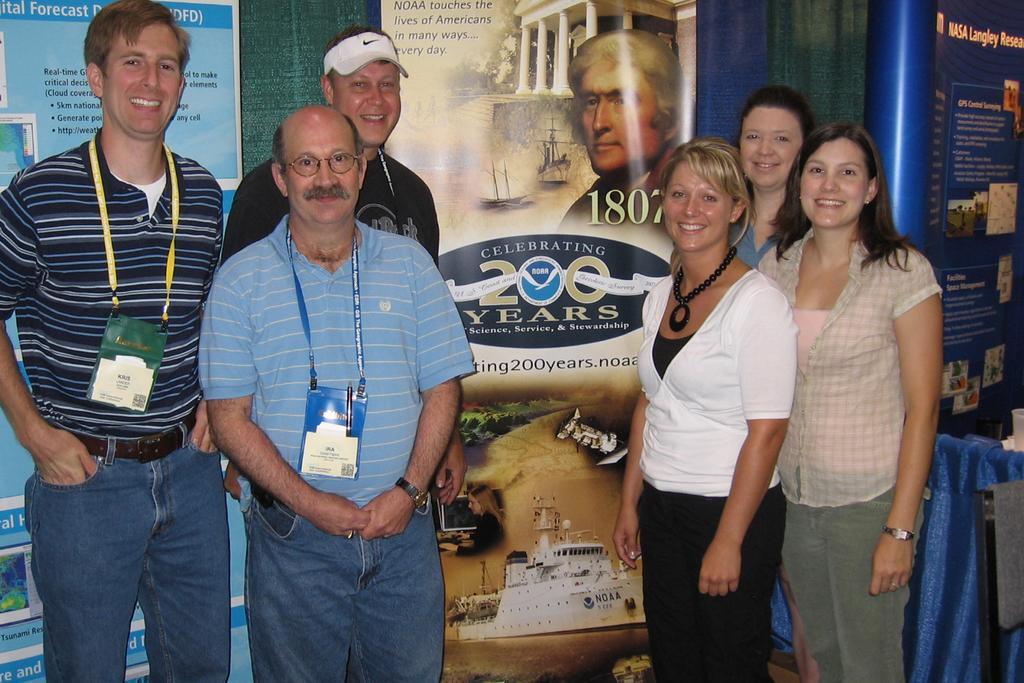How would you summarize this image in a sentence or two? In this image I can see group of people standing, the person in front wearing blue shirt, blue pant and I can also see a badge which is in blue color. Background I can see few banners attached to the wall, they are in blue and white color. 